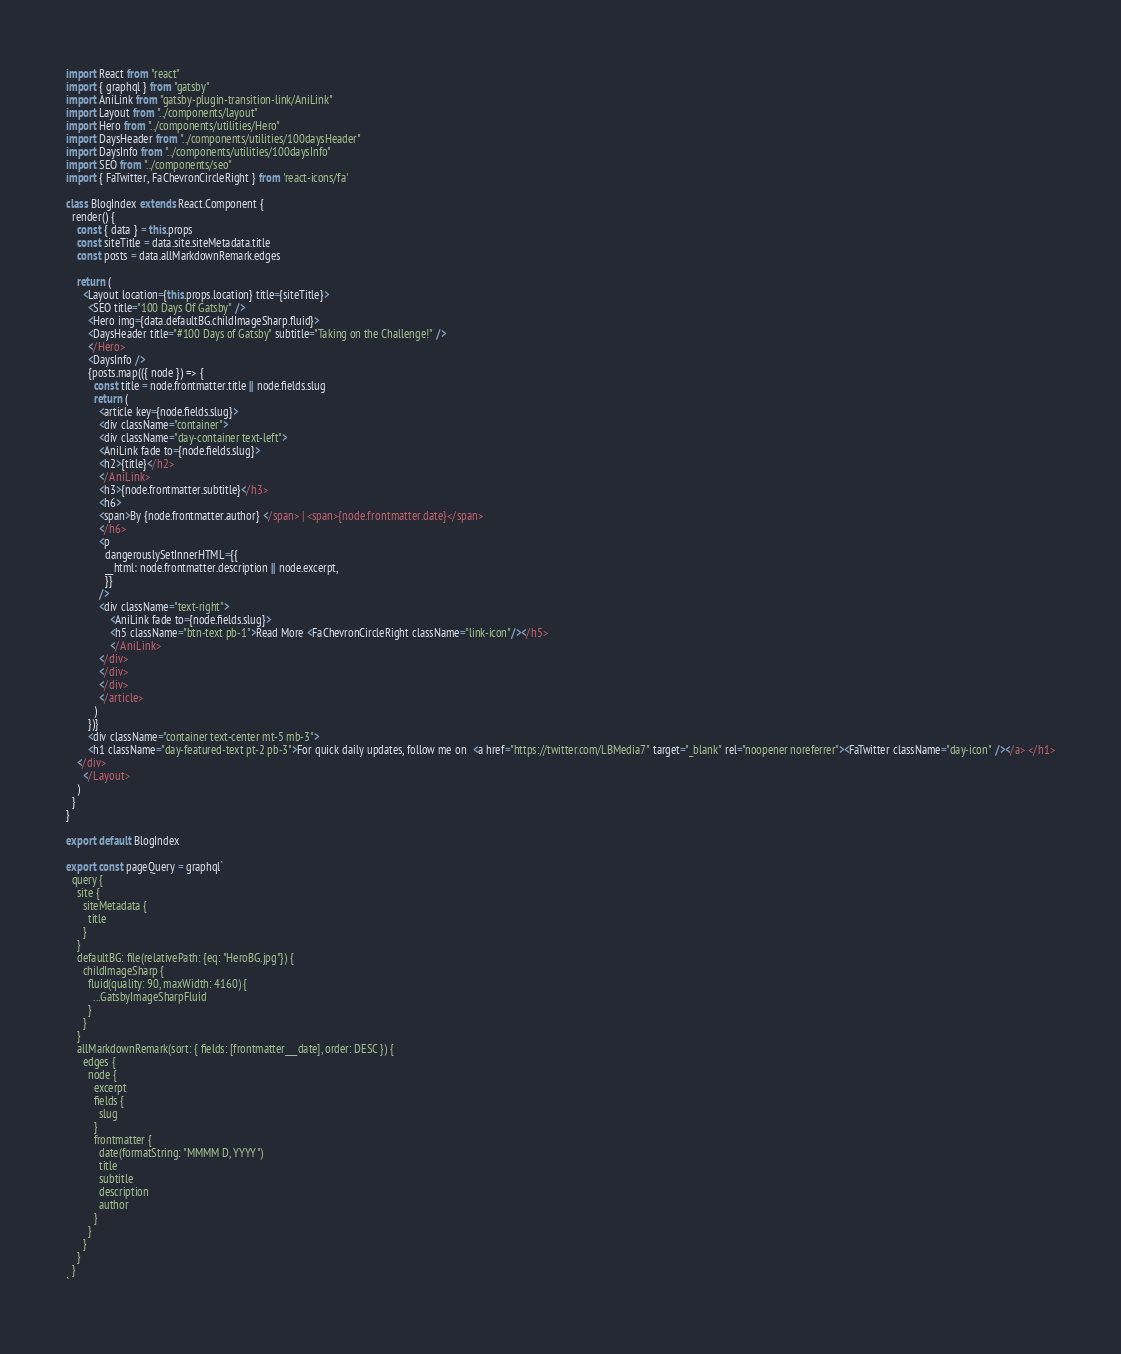Convert code to text. <code><loc_0><loc_0><loc_500><loc_500><_JavaScript_>import React from "react"
import { graphql } from "gatsby"
import AniLink from "gatsby-plugin-transition-link/AniLink"
import Layout from "../components/layout"
import Hero from "../components/utilities/Hero"
import DaysHeader from "../components/utilities/100daysHeader"
import DaysInfo from "../components/utilities/100daysInfo"
import SEO from "../components/seo"
import { FaTwitter, FaChevronCircleRight } from 'react-icons/fa'

class BlogIndex extends React.Component {
  render() {
    const { data } = this.props
    const siteTitle = data.site.siteMetadata.title
    const posts = data.allMarkdownRemark.edges

    return (
      <Layout location={this.props.location} title={siteTitle}>
        <SEO title="100 Days Of Gatsby" />
        <Hero img={data.defaultBG.childImageSharp.fluid}>
        <DaysHeader title="#100 Days of Gatsby" subtitle="Taking on the Challenge!" />
        </Hero>
        <DaysInfo />
        {posts.map(({ node }) => {
          const title = node.frontmatter.title || node.fields.slug
          return (
            <article key={node.fields.slug}>
            <div className="container">
            <div className="day-container text-left">
            <AniLink fade to={node.fields.slug}>
            <h2>{title}</h2>
            </AniLink>
            <h3>{node.frontmatter.subtitle}</h3>
            <h6>
            <span>By {node.frontmatter.author} </span> | <span>{node.frontmatter.date}</span>
            </h6>
            <p
              dangerouslySetInnerHTML={{
              __html: node.frontmatter.description || node.excerpt,
              }}
            />
            <div className="text-right">
                <AniLink fade to={node.fields.slug}>
                <h5 className="btn-text pb-1">Read More <FaChevronCircleRight className="link-icon"/></h5>
                </AniLink>
            </div>
            </div>
            </div>
            </article>
          )
        })}
        <div className="container text-center mt-5 mb-3">
        <h1 className="day-featured-text pt-2 pb-3">For quick daily updates, follow me on  <a href="https://twitter.com/LBMedia7" target="_blank" rel="noopener noreferrer"><FaTwitter className="day-icon" /></a> </h1>
    </div>
      </Layout>
    )
  }
}

export default BlogIndex

export const pageQuery = graphql`
  query {
    site {
      siteMetadata {
        title
      }
    }
    defaultBG: file(relativePath: {eq: "HeroBG.jpg"}) {
      childImageSharp {
        fluid(quality: 90, maxWidth: 4160) {
          ...GatsbyImageSharpFluid
        }
      }
    }
    allMarkdownRemark(sort: { fields: [frontmatter___date], order: DESC }) {
      edges {
        node {
          excerpt
          fields {
            slug
          }
          frontmatter {
            date(formatString: "MMMM D, YYYY")
            title
            subtitle
            description
            author
          }
        }
      }
    }
  }
`
</code> 